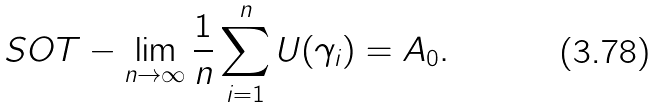Convert formula to latex. <formula><loc_0><loc_0><loc_500><loc_500>S O T - \lim _ { n \to \infty } \frac { 1 } { n } \sum _ { i = 1 } ^ { n } U ( \gamma _ { i } ) = A _ { 0 } .</formula> 